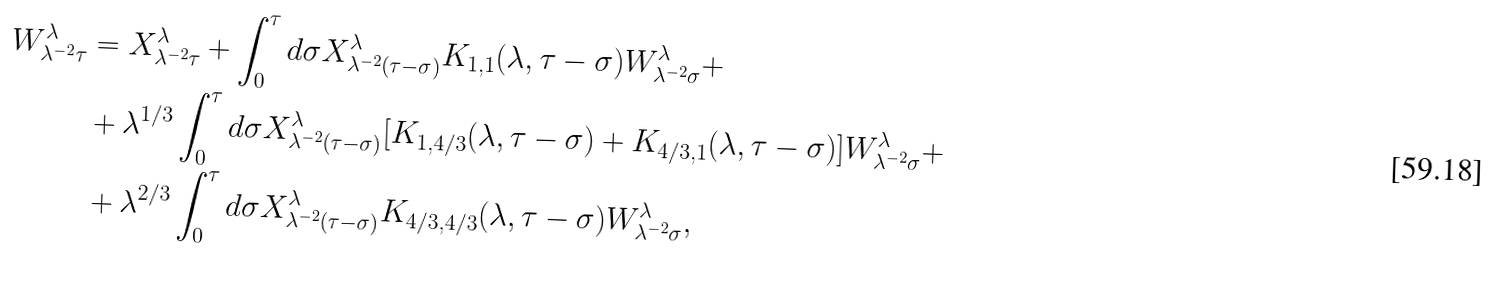Convert formula to latex. <formula><loc_0><loc_0><loc_500><loc_500>W _ { \lambda ^ { - 2 } \tau } ^ { \lambda } & = X _ { \lambda ^ { - 2 } \tau } ^ { \lambda } + \int _ { 0 } ^ { \tau } d \sigma X _ { \lambda ^ { - 2 } ( \tau - \sigma ) } ^ { \lambda } K _ { 1 , 1 } ( \lambda , \tau - \sigma ) W _ { \lambda ^ { - 2 } \sigma } ^ { \lambda } + \\ & + \lambda ^ { 1 / 3 } \int _ { 0 } ^ { \tau } d \sigma X _ { \lambda ^ { - 2 } ( \tau - \sigma ) } ^ { \lambda } [ K _ { 1 , 4 / 3 } ( \lambda , \tau - \sigma ) + K _ { 4 / 3 , 1 } ( \lambda , \tau - \sigma ) ] W _ { \lambda ^ { - 2 } \sigma } ^ { \lambda } + \\ & + \lambda ^ { 2 / 3 } \int _ { 0 } ^ { \tau } d \sigma X _ { \lambda ^ { - 2 } ( \tau - \sigma ) } ^ { \lambda } K _ { 4 / 3 , 4 / 3 } ( \lambda , \tau - \sigma ) W _ { \lambda ^ { - 2 } \sigma } ^ { \lambda } ,</formula> 